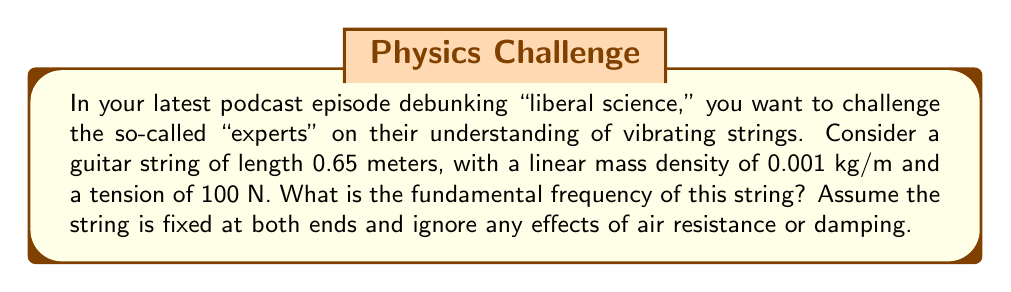Provide a solution to this math problem. Let's approach this step-by-step using the wave equation for a vibrating string:

1) The wave equation for a vibrating string is:

   $$\frac{\partial^2 y}{\partial t^2} = v^2 \frac{\partial^2 y}{\partial x^2}$$

   where $v$ is the wave speed.

2) For a string fixed at both ends, the fundamental frequency $f$ is given by:

   $$f = \frac{v}{2L}$$

   where $L$ is the length of the string.

3) The wave speed $v$ in a string is given by:

   $$v = \sqrt{\frac{T}{\mu}}$$

   where $T$ is the tension and $\mu$ is the linear mass density.

4) Given:
   - Length $L = 0.65$ m
   - Linear mass density $\mu = 0.001$ kg/m
   - Tension $T = 100$ N

5) Calculate the wave speed:

   $$v = \sqrt{\frac{T}{\mu}} = \sqrt{\frac{100}{0.001}} = \sqrt{100000} = 316.23 \text{ m/s}$$

6) Now, calculate the fundamental frequency:

   $$f = \frac{v}{2L} = \frac{316.23}{2(0.65)} = 243.25 \text{ Hz}$$

7) Round to two decimal places: 243.25 Hz
Answer: 243.25 Hz 